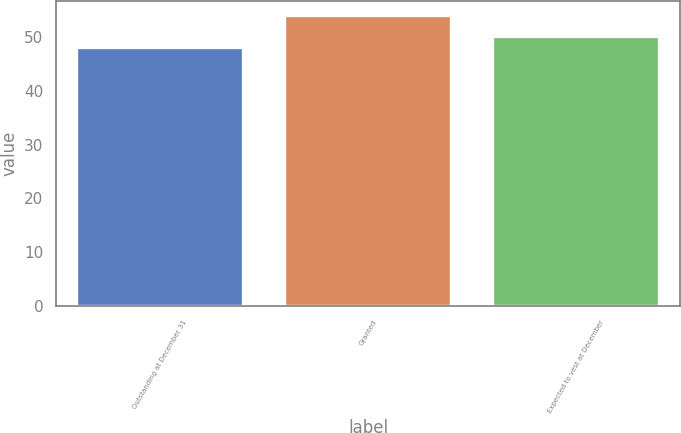<chart> <loc_0><loc_0><loc_500><loc_500><bar_chart><fcel>Outstanding at December 31<fcel>Granted<fcel>Expected to vest at December<nl><fcel>48<fcel>54<fcel>50<nl></chart> 